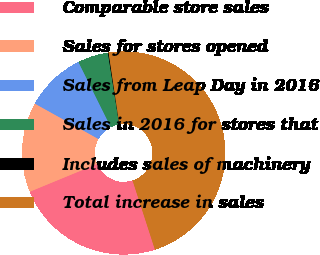<chart> <loc_0><loc_0><loc_500><loc_500><pie_chart><fcel>Comparable store sales<fcel>Sales for stores opened<fcel>Sales from Leap Day in 2016<fcel>Sales in 2016 for stores that<fcel>Includes sales of machinery<fcel>Total increase in sales<nl><fcel>23.76%<fcel>14.3%<fcel>9.58%<fcel>4.85%<fcel>0.12%<fcel>47.39%<nl></chart> 